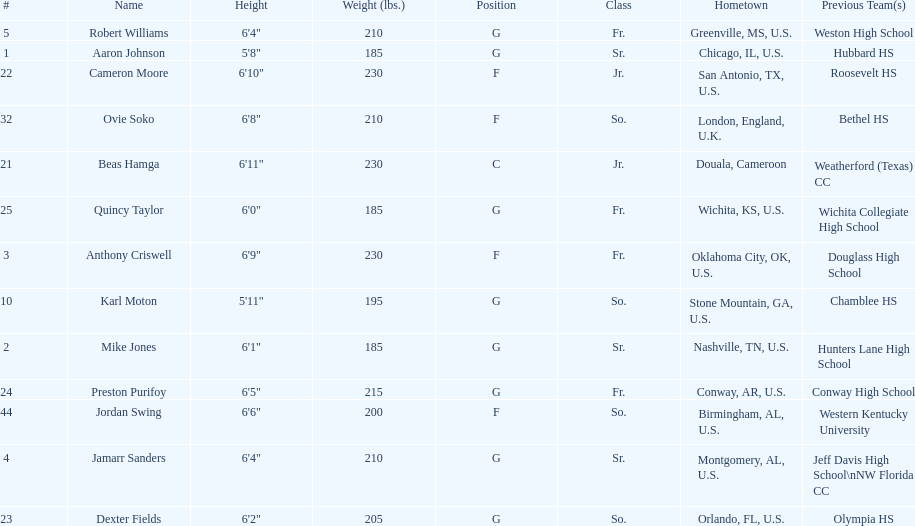What is the quantity of seniors on the team? 3. 